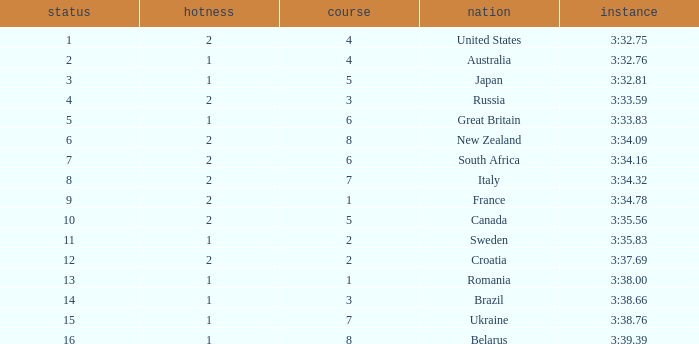Can you tell me the Time that has the Heat of 1, and the Lane of 2? 3:35.83. 